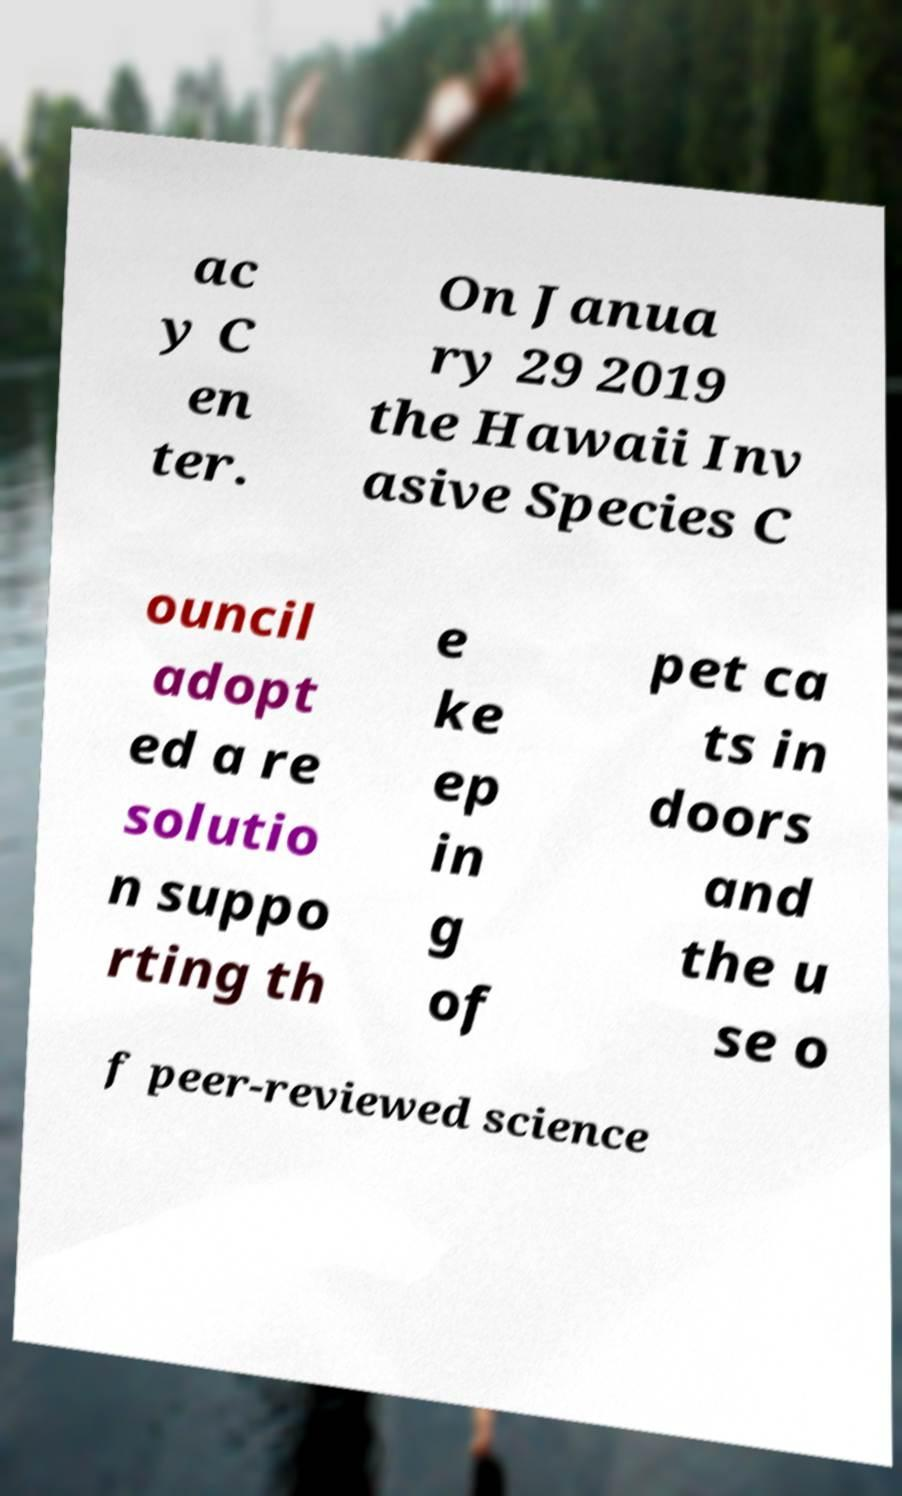I need the written content from this picture converted into text. Can you do that? ac y C en ter. On Janua ry 29 2019 the Hawaii Inv asive Species C ouncil adopt ed a re solutio n suppo rting th e ke ep in g of pet ca ts in doors and the u se o f peer-reviewed science 